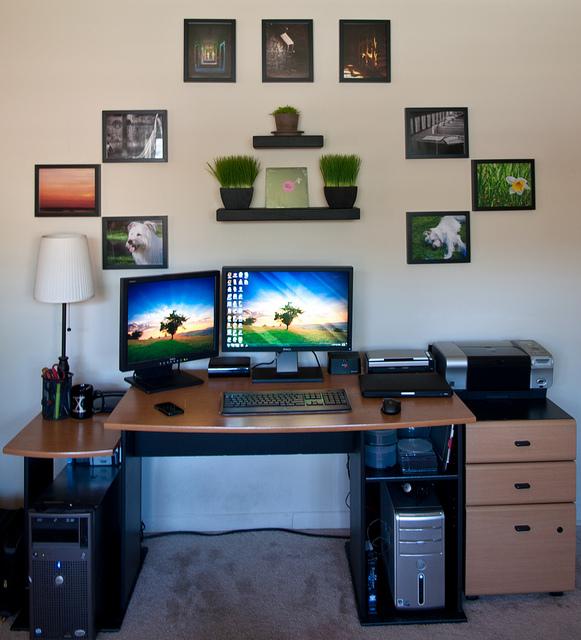How many screens does this computer have?
Short answer required. 2. What  item is behind the desk?
Short answer required. Pictures. What type of lamp is on the desk?
Quick response, please. Table lamp. How many pictures are on the wall?
Answer briefly. 9. What is in the carton next to the computer on the right?
Be succinct. Printer. What type of video game system is on the desk?
Keep it brief. Pc. Are these reference books?
Keep it brief. No. What is on the bottom floating shelf?
Answer briefly. Plants. Does this look like a music studio?
Concise answer only. No. 